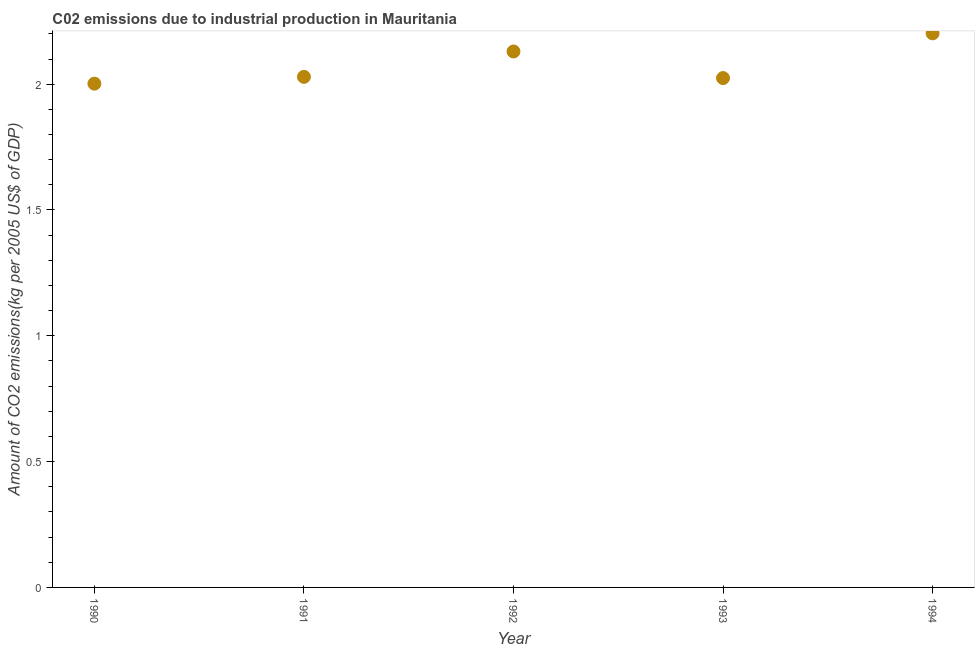What is the amount of co2 emissions in 1990?
Your response must be concise. 2. Across all years, what is the maximum amount of co2 emissions?
Make the answer very short. 2.2. Across all years, what is the minimum amount of co2 emissions?
Offer a very short reply. 2. In which year was the amount of co2 emissions maximum?
Provide a short and direct response. 1994. In which year was the amount of co2 emissions minimum?
Provide a succinct answer. 1990. What is the sum of the amount of co2 emissions?
Your answer should be very brief. 10.39. What is the difference between the amount of co2 emissions in 1990 and 1991?
Offer a terse response. -0.03. What is the average amount of co2 emissions per year?
Your answer should be compact. 2.08. What is the median amount of co2 emissions?
Provide a short and direct response. 2.03. In how many years, is the amount of co2 emissions greater than 1.7 kg per 2005 US$ of GDP?
Keep it short and to the point. 5. Do a majority of the years between 1990 and 1994 (inclusive) have amount of co2 emissions greater than 1.2 kg per 2005 US$ of GDP?
Give a very brief answer. Yes. What is the ratio of the amount of co2 emissions in 1992 to that in 1994?
Your answer should be compact. 0.97. Is the amount of co2 emissions in 1990 less than that in 1992?
Your response must be concise. Yes. What is the difference between the highest and the second highest amount of co2 emissions?
Offer a terse response. 0.07. What is the difference between the highest and the lowest amount of co2 emissions?
Your answer should be compact. 0.2. In how many years, is the amount of co2 emissions greater than the average amount of co2 emissions taken over all years?
Give a very brief answer. 2. How many years are there in the graph?
Your answer should be very brief. 5. Are the values on the major ticks of Y-axis written in scientific E-notation?
Offer a terse response. No. Does the graph contain any zero values?
Keep it short and to the point. No. Does the graph contain grids?
Your response must be concise. No. What is the title of the graph?
Your response must be concise. C02 emissions due to industrial production in Mauritania. What is the label or title of the Y-axis?
Offer a very short reply. Amount of CO2 emissions(kg per 2005 US$ of GDP). What is the Amount of CO2 emissions(kg per 2005 US$ of GDP) in 1990?
Ensure brevity in your answer.  2. What is the Amount of CO2 emissions(kg per 2005 US$ of GDP) in 1991?
Your response must be concise. 2.03. What is the Amount of CO2 emissions(kg per 2005 US$ of GDP) in 1992?
Your answer should be compact. 2.13. What is the Amount of CO2 emissions(kg per 2005 US$ of GDP) in 1993?
Your answer should be compact. 2.02. What is the Amount of CO2 emissions(kg per 2005 US$ of GDP) in 1994?
Your response must be concise. 2.2. What is the difference between the Amount of CO2 emissions(kg per 2005 US$ of GDP) in 1990 and 1991?
Offer a very short reply. -0.03. What is the difference between the Amount of CO2 emissions(kg per 2005 US$ of GDP) in 1990 and 1992?
Your answer should be compact. -0.13. What is the difference between the Amount of CO2 emissions(kg per 2005 US$ of GDP) in 1990 and 1993?
Offer a very short reply. -0.02. What is the difference between the Amount of CO2 emissions(kg per 2005 US$ of GDP) in 1990 and 1994?
Give a very brief answer. -0.2. What is the difference between the Amount of CO2 emissions(kg per 2005 US$ of GDP) in 1991 and 1992?
Offer a very short reply. -0.1. What is the difference between the Amount of CO2 emissions(kg per 2005 US$ of GDP) in 1991 and 1993?
Your response must be concise. 0. What is the difference between the Amount of CO2 emissions(kg per 2005 US$ of GDP) in 1991 and 1994?
Your answer should be compact. -0.17. What is the difference between the Amount of CO2 emissions(kg per 2005 US$ of GDP) in 1992 and 1993?
Provide a short and direct response. 0.11. What is the difference between the Amount of CO2 emissions(kg per 2005 US$ of GDP) in 1992 and 1994?
Your response must be concise. -0.07. What is the difference between the Amount of CO2 emissions(kg per 2005 US$ of GDP) in 1993 and 1994?
Offer a terse response. -0.18. What is the ratio of the Amount of CO2 emissions(kg per 2005 US$ of GDP) in 1990 to that in 1991?
Your answer should be compact. 0.99. What is the ratio of the Amount of CO2 emissions(kg per 2005 US$ of GDP) in 1990 to that in 1992?
Your answer should be very brief. 0.94. What is the ratio of the Amount of CO2 emissions(kg per 2005 US$ of GDP) in 1990 to that in 1993?
Your answer should be compact. 0.99. What is the ratio of the Amount of CO2 emissions(kg per 2005 US$ of GDP) in 1990 to that in 1994?
Provide a succinct answer. 0.91. What is the ratio of the Amount of CO2 emissions(kg per 2005 US$ of GDP) in 1991 to that in 1992?
Your answer should be very brief. 0.95. What is the ratio of the Amount of CO2 emissions(kg per 2005 US$ of GDP) in 1991 to that in 1993?
Provide a short and direct response. 1. What is the ratio of the Amount of CO2 emissions(kg per 2005 US$ of GDP) in 1991 to that in 1994?
Your answer should be very brief. 0.92. What is the ratio of the Amount of CO2 emissions(kg per 2005 US$ of GDP) in 1992 to that in 1993?
Your answer should be compact. 1.05. What is the ratio of the Amount of CO2 emissions(kg per 2005 US$ of GDP) in 1993 to that in 1994?
Provide a short and direct response. 0.92. 